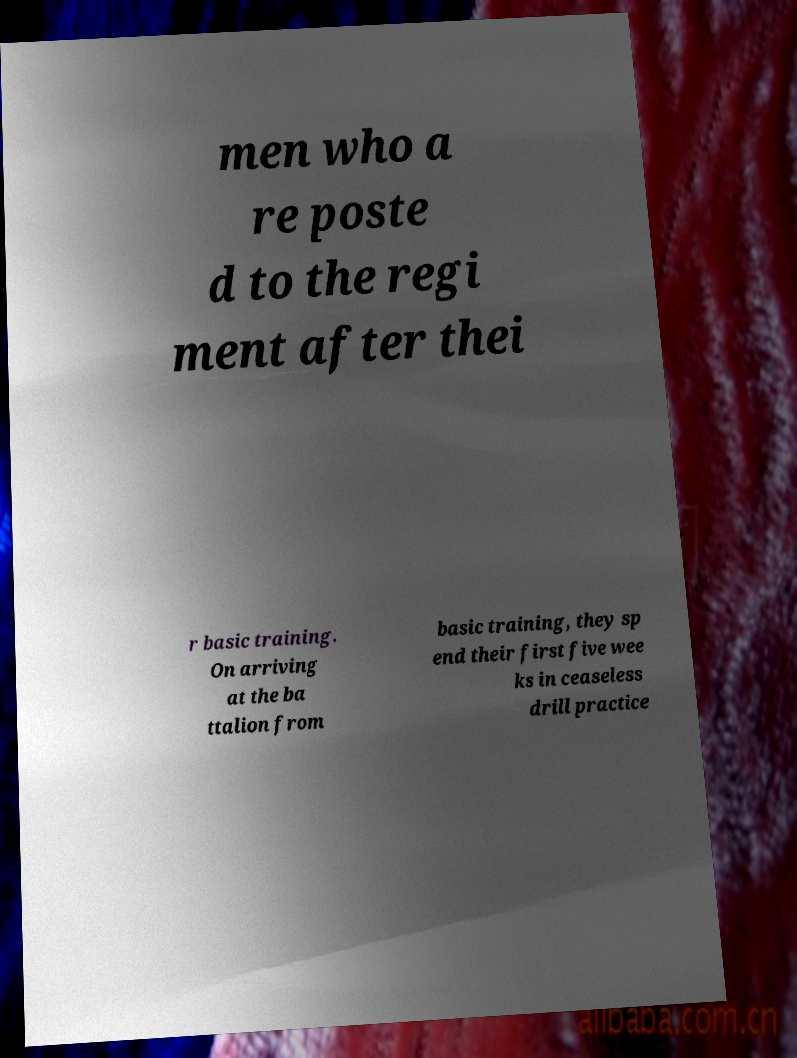For documentation purposes, I need the text within this image transcribed. Could you provide that? men who a re poste d to the regi ment after thei r basic training. On arriving at the ba ttalion from basic training, they sp end their first five wee ks in ceaseless drill practice 